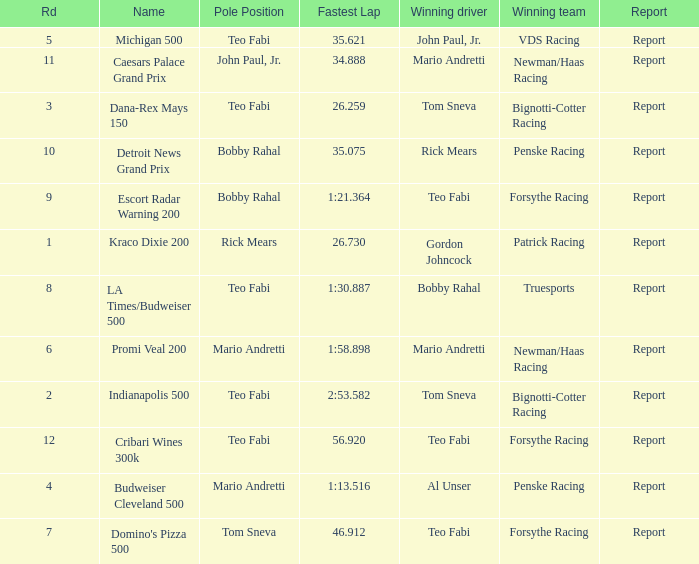Which Rd took place at the Indianapolis 500? 2.0. 